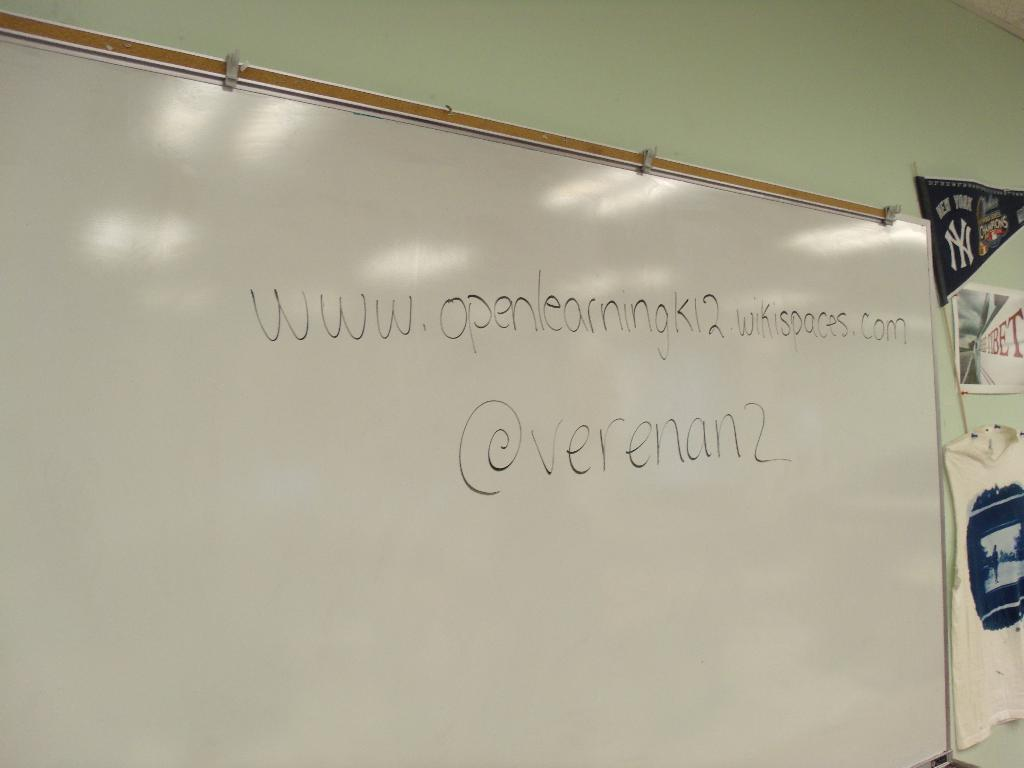<image>
Present a compact description of the photo's key features. A whiteboard has a website written in black that begins openlearningK12. 